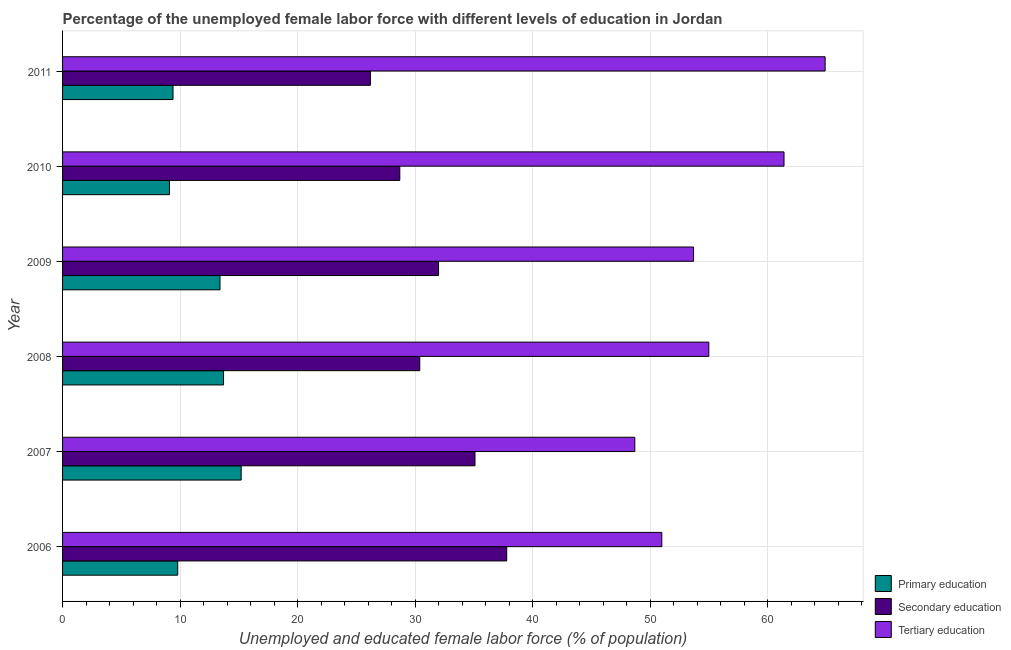How many bars are there on the 1st tick from the top?
Your response must be concise. 3. What is the label of the 2nd group of bars from the top?
Your response must be concise. 2010. In how many cases, is the number of bars for a given year not equal to the number of legend labels?
Offer a terse response. 0. What is the percentage of female labor force who received primary education in 2009?
Provide a succinct answer. 13.4. Across all years, what is the maximum percentage of female labor force who received tertiary education?
Your response must be concise. 64.9. Across all years, what is the minimum percentage of female labor force who received tertiary education?
Keep it short and to the point. 48.7. What is the total percentage of female labor force who received primary education in the graph?
Make the answer very short. 70.6. What is the difference between the percentage of female labor force who received secondary education in 2006 and the percentage of female labor force who received primary education in 2010?
Your answer should be very brief. 28.7. What is the average percentage of female labor force who received tertiary education per year?
Provide a short and direct response. 55.78. In the year 2009, what is the difference between the percentage of female labor force who received primary education and percentage of female labor force who received tertiary education?
Your answer should be compact. -40.3. What is the ratio of the percentage of female labor force who received primary education in 2007 to that in 2010?
Offer a terse response. 1.67. What is the difference between the highest and the lowest percentage of female labor force who received primary education?
Provide a short and direct response. 6.1. In how many years, is the percentage of female labor force who received tertiary education greater than the average percentage of female labor force who received tertiary education taken over all years?
Ensure brevity in your answer.  2. What does the 3rd bar from the bottom in 2010 represents?
Give a very brief answer. Tertiary education. Are all the bars in the graph horizontal?
Make the answer very short. Yes. Are the values on the major ticks of X-axis written in scientific E-notation?
Your response must be concise. No. Does the graph contain any zero values?
Your answer should be very brief. No. Does the graph contain grids?
Provide a short and direct response. Yes. What is the title of the graph?
Offer a terse response. Percentage of the unemployed female labor force with different levels of education in Jordan. Does "Transport equipments" appear as one of the legend labels in the graph?
Your response must be concise. No. What is the label or title of the X-axis?
Give a very brief answer. Unemployed and educated female labor force (% of population). What is the Unemployed and educated female labor force (% of population) of Primary education in 2006?
Your answer should be compact. 9.8. What is the Unemployed and educated female labor force (% of population) in Secondary education in 2006?
Your answer should be very brief. 37.8. What is the Unemployed and educated female labor force (% of population) of Tertiary education in 2006?
Offer a terse response. 51. What is the Unemployed and educated female labor force (% of population) in Primary education in 2007?
Ensure brevity in your answer.  15.2. What is the Unemployed and educated female labor force (% of population) of Secondary education in 2007?
Keep it short and to the point. 35.1. What is the Unemployed and educated female labor force (% of population) in Tertiary education in 2007?
Offer a very short reply. 48.7. What is the Unemployed and educated female labor force (% of population) of Primary education in 2008?
Offer a terse response. 13.7. What is the Unemployed and educated female labor force (% of population) of Secondary education in 2008?
Your answer should be compact. 30.4. What is the Unemployed and educated female labor force (% of population) in Primary education in 2009?
Ensure brevity in your answer.  13.4. What is the Unemployed and educated female labor force (% of population) in Tertiary education in 2009?
Your response must be concise. 53.7. What is the Unemployed and educated female labor force (% of population) of Primary education in 2010?
Ensure brevity in your answer.  9.1. What is the Unemployed and educated female labor force (% of population) in Secondary education in 2010?
Keep it short and to the point. 28.7. What is the Unemployed and educated female labor force (% of population) of Tertiary education in 2010?
Provide a succinct answer. 61.4. What is the Unemployed and educated female labor force (% of population) of Primary education in 2011?
Provide a short and direct response. 9.4. What is the Unemployed and educated female labor force (% of population) in Secondary education in 2011?
Provide a succinct answer. 26.2. What is the Unemployed and educated female labor force (% of population) of Tertiary education in 2011?
Give a very brief answer. 64.9. Across all years, what is the maximum Unemployed and educated female labor force (% of population) in Primary education?
Give a very brief answer. 15.2. Across all years, what is the maximum Unemployed and educated female labor force (% of population) of Secondary education?
Your response must be concise. 37.8. Across all years, what is the maximum Unemployed and educated female labor force (% of population) in Tertiary education?
Ensure brevity in your answer.  64.9. Across all years, what is the minimum Unemployed and educated female labor force (% of population) in Primary education?
Make the answer very short. 9.1. Across all years, what is the minimum Unemployed and educated female labor force (% of population) of Secondary education?
Offer a very short reply. 26.2. Across all years, what is the minimum Unemployed and educated female labor force (% of population) of Tertiary education?
Make the answer very short. 48.7. What is the total Unemployed and educated female labor force (% of population) in Primary education in the graph?
Provide a short and direct response. 70.6. What is the total Unemployed and educated female labor force (% of population) of Secondary education in the graph?
Give a very brief answer. 190.2. What is the total Unemployed and educated female labor force (% of population) in Tertiary education in the graph?
Keep it short and to the point. 334.7. What is the difference between the Unemployed and educated female labor force (% of population) of Primary education in 2006 and that in 2007?
Give a very brief answer. -5.4. What is the difference between the Unemployed and educated female labor force (% of population) in Tertiary education in 2006 and that in 2008?
Keep it short and to the point. -4. What is the difference between the Unemployed and educated female labor force (% of population) in Primary education in 2006 and that in 2009?
Your response must be concise. -3.6. What is the difference between the Unemployed and educated female labor force (% of population) of Secondary education in 2006 and that in 2010?
Provide a succinct answer. 9.1. What is the difference between the Unemployed and educated female labor force (% of population) in Tertiary education in 2006 and that in 2010?
Give a very brief answer. -10.4. What is the difference between the Unemployed and educated female labor force (% of population) of Secondary education in 2006 and that in 2011?
Your answer should be very brief. 11.6. What is the difference between the Unemployed and educated female labor force (% of population) in Tertiary education in 2006 and that in 2011?
Your response must be concise. -13.9. What is the difference between the Unemployed and educated female labor force (% of population) of Primary education in 2007 and that in 2008?
Make the answer very short. 1.5. What is the difference between the Unemployed and educated female labor force (% of population) of Secondary education in 2007 and that in 2008?
Ensure brevity in your answer.  4.7. What is the difference between the Unemployed and educated female labor force (% of population) in Secondary education in 2007 and that in 2009?
Offer a terse response. 3.1. What is the difference between the Unemployed and educated female labor force (% of population) of Tertiary education in 2007 and that in 2009?
Offer a very short reply. -5. What is the difference between the Unemployed and educated female labor force (% of population) of Primary education in 2007 and that in 2010?
Your answer should be compact. 6.1. What is the difference between the Unemployed and educated female labor force (% of population) in Secondary education in 2007 and that in 2010?
Offer a very short reply. 6.4. What is the difference between the Unemployed and educated female labor force (% of population) of Secondary education in 2007 and that in 2011?
Make the answer very short. 8.9. What is the difference between the Unemployed and educated female labor force (% of population) of Tertiary education in 2007 and that in 2011?
Give a very brief answer. -16.2. What is the difference between the Unemployed and educated female labor force (% of population) of Tertiary education in 2008 and that in 2009?
Ensure brevity in your answer.  1.3. What is the difference between the Unemployed and educated female labor force (% of population) in Tertiary education in 2008 and that in 2010?
Provide a short and direct response. -6.4. What is the difference between the Unemployed and educated female labor force (% of population) of Primary education in 2008 and that in 2011?
Give a very brief answer. 4.3. What is the difference between the Unemployed and educated female labor force (% of population) in Tertiary education in 2008 and that in 2011?
Offer a terse response. -9.9. What is the difference between the Unemployed and educated female labor force (% of population) in Secondary education in 2009 and that in 2010?
Make the answer very short. 3.3. What is the difference between the Unemployed and educated female labor force (% of population) of Tertiary education in 2009 and that in 2011?
Offer a very short reply. -11.2. What is the difference between the Unemployed and educated female labor force (% of population) of Primary education in 2010 and that in 2011?
Your answer should be very brief. -0.3. What is the difference between the Unemployed and educated female labor force (% of population) of Secondary education in 2010 and that in 2011?
Make the answer very short. 2.5. What is the difference between the Unemployed and educated female labor force (% of population) of Tertiary education in 2010 and that in 2011?
Your response must be concise. -3.5. What is the difference between the Unemployed and educated female labor force (% of population) in Primary education in 2006 and the Unemployed and educated female labor force (% of population) in Secondary education in 2007?
Provide a succinct answer. -25.3. What is the difference between the Unemployed and educated female labor force (% of population) of Primary education in 2006 and the Unemployed and educated female labor force (% of population) of Tertiary education in 2007?
Your answer should be compact. -38.9. What is the difference between the Unemployed and educated female labor force (% of population) in Primary education in 2006 and the Unemployed and educated female labor force (% of population) in Secondary education in 2008?
Ensure brevity in your answer.  -20.6. What is the difference between the Unemployed and educated female labor force (% of population) of Primary education in 2006 and the Unemployed and educated female labor force (% of population) of Tertiary education in 2008?
Provide a short and direct response. -45.2. What is the difference between the Unemployed and educated female labor force (% of population) of Secondary education in 2006 and the Unemployed and educated female labor force (% of population) of Tertiary education in 2008?
Keep it short and to the point. -17.2. What is the difference between the Unemployed and educated female labor force (% of population) in Primary education in 2006 and the Unemployed and educated female labor force (% of population) in Secondary education in 2009?
Provide a short and direct response. -22.2. What is the difference between the Unemployed and educated female labor force (% of population) of Primary education in 2006 and the Unemployed and educated female labor force (% of population) of Tertiary education in 2009?
Your answer should be very brief. -43.9. What is the difference between the Unemployed and educated female labor force (% of population) of Secondary education in 2006 and the Unemployed and educated female labor force (% of population) of Tertiary education in 2009?
Provide a short and direct response. -15.9. What is the difference between the Unemployed and educated female labor force (% of population) of Primary education in 2006 and the Unemployed and educated female labor force (% of population) of Secondary education in 2010?
Your answer should be compact. -18.9. What is the difference between the Unemployed and educated female labor force (% of population) in Primary education in 2006 and the Unemployed and educated female labor force (% of population) in Tertiary education in 2010?
Provide a succinct answer. -51.6. What is the difference between the Unemployed and educated female labor force (% of population) of Secondary education in 2006 and the Unemployed and educated female labor force (% of population) of Tertiary education in 2010?
Offer a terse response. -23.6. What is the difference between the Unemployed and educated female labor force (% of population) in Primary education in 2006 and the Unemployed and educated female labor force (% of population) in Secondary education in 2011?
Your response must be concise. -16.4. What is the difference between the Unemployed and educated female labor force (% of population) in Primary education in 2006 and the Unemployed and educated female labor force (% of population) in Tertiary education in 2011?
Give a very brief answer. -55.1. What is the difference between the Unemployed and educated female labor force (% of population) of Secondary education in 2006 and the Unemployed and educated female labor force (% of population) of Tertiary education in 2011?
Your answer should be very brief. -27.1. What is the difference between the Unemployed and educated female labor force (% of population) in Primary education in 2007 and the Unemployed and educated female labor force (% of population) in Secondary education in 2008?
Make the answer very short. -15.2. What is the difference between the Unemployed and educated female labor force (% of population) of Primary education in 2007 and the Unemployed and educated female labor force (% of population) of Tertiary education in 2008?
Provide a succinct answer. -39.8. What is the difference between the Unemployed and educated female labor force (% of population) in Secondary education in 2007 and the Unemployed and educated female labor force (% of population) in Tertiary education in 2008?
Provide a succinct answer. -19.9. What is the difference between the Unemployed and educated female labor force (% of population) of Primary education in 2007 and the Unemployed and educated female labor force (% of population) of Secondary education in 2009?
Offer a terse response. -16.8. What is the difference between the Unemployed and educated female labor force (% of population) of Primary education in 2007 and the Unemployed and educated female labor force (% of population) of Tertiary education in 2009?
Offer a very short reply. -38.5. What is the difference between the Unemployed and educated female labor force (% of population) in Secondary education in 2007 and the Unemployed and educated female labor force (% of population) in Tertiary education in 2009?
Provide a short and direct response. -18.6. What is the difference between the Unemployed and educated female labor force (% of population) in Primary education in 2007 and the Unemployed and educated female labor force (% of population) in Secondary education in 2010?
Give a very brief answer. -13.5. What is the difference between the Unemployed and educated female labor force (% of population) of Primary education in 2007 and the Unemployed and educated female labor force (% of population) of Tertiary education in 2010?
Provide a succinct answer. -46.2. What is the difference between the Unemployed and educated female labor force (% of population) of Secondary education in 2007 and the Unemployed and educated female labor force (% of population) of Tertiary education in 2010?
Offer a terse response. -26.3. What is the difference between the Unemployed and educated female labor force (% of population) of Primary education in 2007 and the Unemployed and educated female labor force (% of population) of Tertiary education in 2011?
Provide a succinct answer. -49.7. What is the difference between the Unemployed and educated female labor force (% of population) in Secondary education in 2007 and the Unemployed and educated female labor force (% of population) in Tertiary education in 2011?
Ensure brevity in your answer.  -29.8. What is the difference between the Unemployed and educated female labor force (% of population) in Primary education in 2008 and the Unemployed and educated female labor force (% of population) in Secondary education in 2009?
Keep it short and to the point. -18.3. What is the difference between the Unemployed and educated female labor force (% of population) in Primary education in 2008 and the Unemployed and educated female labor force (% of population) in Tertiary education in 2009?
Keep it short and to the point. -40. What is the difference between the Unemployed and educated female labor force (% of population) in Secondary education in 2008 and the Unemployed and educated female labor force (% of population) in Tertiary education in 2009?
Give a very brief answer. -23.3. What is the difference between the Unemployed and educated female labor force (% of population) of Primary education in 2008 and the Unemployed and educated female labor force (% of population) of Tertiary education in 2010?
Your answer should be compact. -47.7. What is the difference between the Unemployed and educated female labor force (% of population) in Secondary education in 2008 and the Unemployed and educated female labor force (% of population) in Tertiary education in 2010?
Your response must be concise. -31. What is the difference between the Unemployed and educated female labor force (% of population) of Primary education in 2008 and the Unemployed and educated female labor force (% of population) of Secondary education in 2011?
Your answer should be very brief. -12.5. What is the difference between the Unemployed and educated female labor force (% of population) in Primary education in 2008 and the Unemployed and educated female labor force (% of population) in Tertiary education in 2011?
Keep it short and to the point. -51.2. What is the difference between the Unemployed and educated female labor force (% of population) of Secondary education in 2008 and the Unemployed and educated female labor force (% of population) of Tertiary education in 2011?
Make the answer very short. -34.5. What is the difference between the Unemployed and educated female labor force (% of population) of Primary education in 2009 and the Unemployed and educated female labor force (% of population) of Secondary education in 2010?
Keep it short and to the point. -15.3. What is the difference between the Unemployed and educated female labor force (% of population) of Primary education in 2009 and the Unemployed and educated female labor force (% of population) of Tertiary education in 2010?
Provide a short and direct response. -48. What is the difference between the Unemployed and educated female labor force (% of population) in Secondary education in 2009 and the Unemployed and educated female labor force (% of population) in Tertiary education in 2010?
Provide a succinct answer. -29.4. What is the difference between the Unemployed and educated female labor force (% of population) in Primary education in 2009 and the Unemployed and educated female labor force (% of population) in Tertiary education in 2011?
Ensure brevity in your answer.  -51.5. What is the difference between the Unemployed and educated female labor force (% of population) of Secondary education in 2009 and the Unemployed and educated female labor force (% of population) of Tertiary education in 2011?
Your response must be concise. -32.9. What is the difference between the Unemployed and educated female labor force (% of population) of Primary education in 2010 and the Unemployed and educated female labor force (% of population) of Secondary education in 2011?
Your answer should be compact. -17.1. What is the difference between the Unemployed and educated female labor force (% of population) in Primary education in 2010 and the Unemployed and educated female labor force (% of population) in Tertiary education in 2011?
Your response must be concise. -55.8. What is the difference between the Unemployed and educated female labor force (% of population) in Secondary education in 2010 and the Unemployed and educated female labor force (% of population) in Tertiary education in 2011?
Provide a short and direct response. -36.2. What is the average Unemployed and educated female labor force (% of population) in Primary education per year?
Provide a short and direct response. 11.77. What is the average Unemployed and educated female labor force (% of population) in Secondary education per year?
Your answer should be compact. 31.7. What is the average Unemployed and educated female labor force (% of population) in Tertiary education per year?
Keep it short and to the point. 55.78. In the year 2006, what is the difference between the Unemployed and educated female labor force (% of population) in Primary education and Unemployed and educated female labor force (% of population) in Secondary education?
Ensure brevity in your answer.  -28. In the year 2006, what is the difference between the Unemployed and educated female labor force (% of population) of Primary education and Unemployed and educated female labor force (% of population) of Tertiary education?
Provide a succinct answer. -41.2. In the year 2007, what is the difference between the Unemployed and educated female labor force (% of population) of Primary education and Unemployed and educated female labor force (% of population) of Secondary education?
Keep it short and to the point. -19.9. In the year 2007, what is the difference between the Unemployed and educated female labor force (% of population) of Primary education and Unemployed and educated female labor force (% of population) of Tertiary education?
Your answer should be compact. -33.5. In the year 2008, what is the difference between the Unemployed and educated female labor force (% of population) of Primary education and Unemployed and educated female labor force (% of population) of Secondary education?
Offer a terse response. -16.7. In the year 2008, what is the difference between the Unemployed and educated female labor force (% of population) of Primary education and Unemployed and educated female labor force (% of population) of Tertiary education?
Give a very brief answer. -41.3. In the year 2008, what is the difference between the Unemployed and educated female labor force (% of population) of Secondary education and Unemployed and educated female labor force (% of population) of Tertiary education?
Give a very brief answer. -24.6. In the year 2009, what is the difference between the Unemployed and educated female labor force (% of population) in Primary education and Unemployed and educated female labor force (% of population) in Secondary education?
Give a very brief answer. -18.6. In the year 2009, what is the difference between the Unemployed and educated female labor force (% of population) of Primary education and Unemployed and educated female labor force (% of population) of Tertiary education?
Keep it short and to the point. -40.3. In the year 2009, what is the difference between the Unemployed and educated female labor force (% of population) of Secondary education and Unemployed and educated female labor force (% of population) of Tertiary education?
Ensure brevity in your answer.  -21.7. In the year 2010, what is the difference between the Unemployed and educated female labor force (% of population) of Primary education and Unemployed and educated female labor force (% of population) of Secondary education?
Ensure brevity in your answer.  -19.6. In the year 2010, what is the difference between the Unemployed and educated female labor force (% of population) of Primary education and Unemployed and educated female labor force (% of population) of Tertiary education?
Offer a very short reply. -52.3. In the year 2010, what is the difference between the Unemployed and educated female labor force (% of population) of Secondary education and Unemployed and educated female labor force (% of population) of Tertiary education?
Provide a short and direct response. -32.7. In the year 2011, what is the difference between the Unemployed and educated female labor force (% of population) of Primary education and Unemployed and educated female labor force (% of population) of Secondary education?
Provide a succinct answer. -16.8. In the year 2011, what is the difference between the Unemployed and educated female labor force (% of population) of Primary education and Unemployed and educated female labor force (% of population) of Tertiary education?
Ensure brevity in your answer.  -55.5. In the year 2011, what is the difference between the Unemployed and educated female labor force (% of population) of Secondary education and Unemployed and educated female labor force (% of population) of Tertiary education?
Offer a very short reply. -38.7. What is the ratio of the Unemployed and educated female labor force (% of population) in Primary education in 2006 to that in 2007?
Provide a succinct answer. 0.64. What is the ratio of the Unemployed and educated female labor force (% of population) of Tertiary education in 2006 to that in 2007?
Keep it short and to the point. 1.05. What is the ratio of the Unemployed and educated female labor force (% of population) of Primary education in 2006 to that in 2008?
Offer a terse response. 0.72. What is the ratio of the Unemployed and educated female labor force (% of population) of Secondary education in 2006 to that in 2008?
Your answer should be compact. 1.24. What is the ratio of the Unemployed and educated female labor force (% of population) of Tertiary education in 2006 to that in 2008?
Your answer should be very brief. 0.93. What is the ratio of the Unemployed and educated female labor force (% of population) in Primary education in 2006 to that in 2009?
Provide a short and direct response. 0.73. What is the ratio of the Unemployed and educated female labor force (% of population) in Secondary education in 2006 to that in 2009?
Offer a very short reply. 1.18. What is the ratio of the Unemployed and educated female labor force (% of population) in Tertiary education in 2006 to that in 2009?
Offer a very short reply. 0.95. What is the ratio of the Unemployed and educated female labor force (% of population) of Secondary education in 2006 to that in 2010?
Offer a terse response. 1.32. What is the ratio of the Unemployed and educated female labor force (% of population) of Tertiary education in 2006 to that in 2010?
Keep it short and to the point. 0.83. What is the ratio of the Unemployed and educated female labor force (% of population) in Primary education in 2006 to that in 2011?
Offer a terse response. 1.04. What is the ratio of the Unemployed and educated female labor force (% of population) of Secondary education in 2006 to that in 2011?
Keep it short and to the point. 1.44. What is the ratio of the Unemployed and educated female labor force (% of population) of Tertiary education in 2006 to that in 2011?
Make the answer very short. 0.79. What is the ratio of the Unemployed and educated female labor force (% of population) of Primary education in 2007 to that in 2008?
Offer a terse response. 1.11. What is the ratio of the Unemployed and educated female labor force (% of population) in Secondary education in 2007 to that in 2008?
Keep it short and to the point. 1.15. What is the ratio of the Unemployed and educated female labor force (% of population) of Tertiary education in 2007 to that in 2008?
Make the answer very short. 0.89. What is the ratio of the Unemployed and educated female labor force (% of population) of Primary education in 2007 to that in 2009?
Give a very brief answer. 1.13. What is the ratio of the Unemployed and educated female labor force (% of population) in Secondary education in 2007 to that in 2009?
Ensure brevity in your answer.  1.1. What is the ratio of the Unemployed and educated female labor force (% of population) of Tertiary education in 2007 to that in 2009?
Your response must be concise. 0.91. What is the ratio of the Unemployed and educated female labor force (% of population) of Primary education in 2007 to that in 2010?
Your answer should be compact. 1.67. What is the ratio of the Unemployed and educated female labor force (% of population) of Secondary education in 2007 to that in 2010?
Provide a short and direct response. 1.22. What is the ratio of the Unemployed and educated female labor force (% of population) in Tertiary education in 2007 to that in 2010?
Your answer should be compact. 0.79. What is the ratio of the Unemployed and educated female labor force (% of population) in Primary education in 2007 to that in 2011?
Your response must be concise. 1.62. What is the ratio of the Unemployed and educated female labor force (% of population) of Secondary education in 2007 to that in 2011?
Ensure brevity in your answer.  1.34. What is the ratio of the Unemployed and educated female labor force (% of population) of Tertiary education in 2007 to that in 2011?
Provide a succinct answer. 0.75. What is the ratio of the Unemployed and educated female labor force (% of population) of Primary education in 2008 to that in 2009?
Keep it short and to the point. 1.02. What is the ratio of the Unemployed and educated female labor force (% of population) in Secondary education in 2008 to that in 2009?
Give a very brief answer. 0.95. What is the ratio of the Unemployed and educated female labor force (% of population) in Tertiary education in 2008 to that in 2009?
Your answer should be very brief. 1.02. What is the ratio of the Unemployed and educated female labor force (% of population) of Primary education in 2008 to that in 2010?
Provide a succinct answer. 1.51. What is the ratio of the Unemployed and educated female labor force (% of population) of Secondary education in 2008 to that in 2010?
Ensure brevity in your answer.  1.06. What is the ratio of the Unemployed and educated female labor force (% of population) in Tertiary education in 2008 to that in 2010?
Ensure brevity in your answer.  0.9. What is the ratio of the Unemployed and educated female labor force (% of population) of Primary education in 2008 to that in 2011?
Your answer should be very brief. 1.46. What is the ratio of the Unemployed and educated female labor force (% of population) of Secondary education in 2008 to that in 2011?
Your answer should be very brief. 1.16. What is the ratio of the Unemployed and educated female labor force (% of population) in Tertiary education in 2008 to that in 2011?
Offer a terse response. 0.85. What is the ratio of the Unemployed and educated female labor force (% of population) in Primary education in 2009 to that in 2010?
Make the answer very short. 1.47. What is the ratio of the Unemployed and educated female labor force (% of population) of Secondary education in 2009 to that in 2010?
Give a very brief answer. 1.11. What is the ratio of the Unemployed and educated female labor force (% of population) of Tertiary education in 2009 to that in 2010?
Your answer should be very brief. 0.87. What is the ratio of the Unemployed and educated female labor force (% of population) in Primary education in 2009 to that in 2011?
Your response must be concise. 1.43. What is the ratio of the Unemployed and educated female labor force (% of population) in Secondary education in 2009 to that in 2011?
Your response must be concise. 1.22. What is the ratio of the Unemployed and educated female labor force (% of population) of Tertiary education in 2009 to that in 2011?
Your answer should be very brief. 0.83. What is the ratio of the Unemployed and educated female labor force (% of population) of Primary education in 2010 to that in 2011?
Offer a terse response. 0.97. What is the ratio of the Unemployed and educated female labor force (% of population) in Secondary education in 2010 to that in 2011?
Your answer should be very brief. 1.1. What is the ratio of the Unemployed and educated female labor force (% of population) in Tertiary education in 2010 to that in 2011?
Your answer should be compact. 0.95. What is the difference between the highest and the second highest Unemployed and educated female labor force (% of population) of Tertiary education?
Make the answer very short. 3.5. What is the difference between the highest and the lowest Unemployed and educated female labor force (% of population) of Tertiary education?
Your response must be concise. 16.2. 